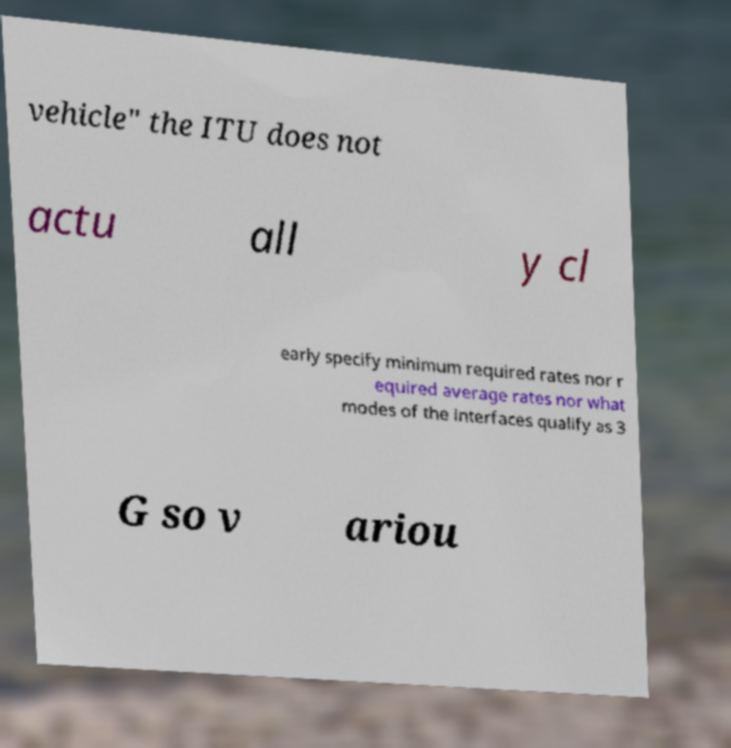Please read and relay the text visible in this image. What does it say? vehicle" the ITU does not actu all y cl early specify minimum required rates nor r equired average rates nor what modes of the interfaces qualify as 3 G so v ariou 